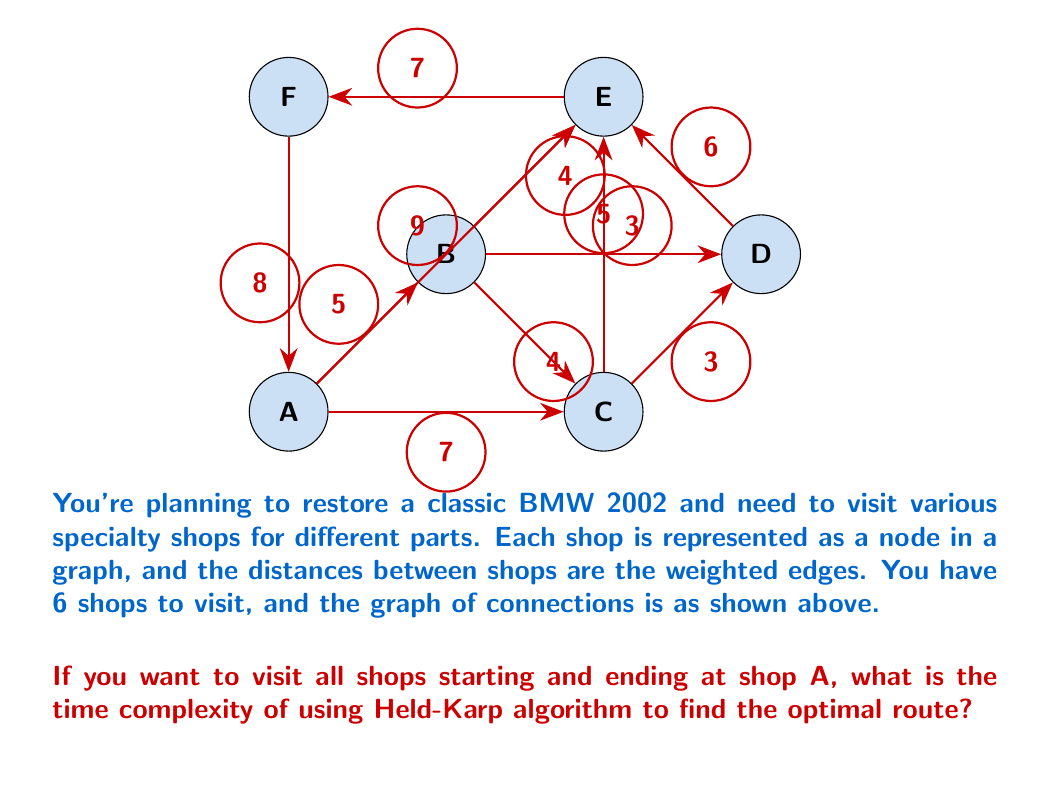Show me your answer to this math problem. To solve this problem, we need to understand the Held-Karp algorithm and its application to the Traveling Salesman Problem (TSP), which is essentially what we're dealing with here.

The Held-Karp algorithm, also known as the Bellman-Held-Karp algorithm, is a dynamic programming solution to the TSP. It works as follows:

1. For each subset of vertices that includes vertex 1 (our starting point A), and each vertex j in that subset, it computes the shortest path from 1 to j that visits each vertex in the subset exactly once.

2. It builds up these solutions iteratively, starting with subsets of size 2 and working up to the full set of vertices.

The time complexity of the Held-Karp algorithm is determined by two factors:

1. The number of subproblems solved
2. The time taken to solve each subproblem

Let's analyze these for a graph with n vertices:

1. Number of subproblems:
   - There are $2^n$ possible subsets of n vertices
   - For each subset, we consider at most n possible end vertices
   - So, the total number of subproblems is $O(n2^n)$

2. Time to solve each subproblem:
   - For each subproblem, we consider at most n possible vertices to connect to
   - So, the time for each subproblem is O(n)

Combining these, the overall time complexity is:

$$O(n^2 2^n)$$

In our specific case, we have 6 shops (vertices), so n = 6. However, the question asks for the time complexity in Big O notation, which is independent of the specific value of n.
Answer: $O(n^2 2^n)$ 